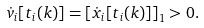Convert formula to latex. <formula><loc_0><loc_0><loc_500><loc_500>\dot { v } _ { i } [ t _ { i } ( k ) ] = { \left [ { \dot { x } _ { i } [ t _ { i } ( k ) ] } \right ] } _ { 1 } > 0 .</formula> 